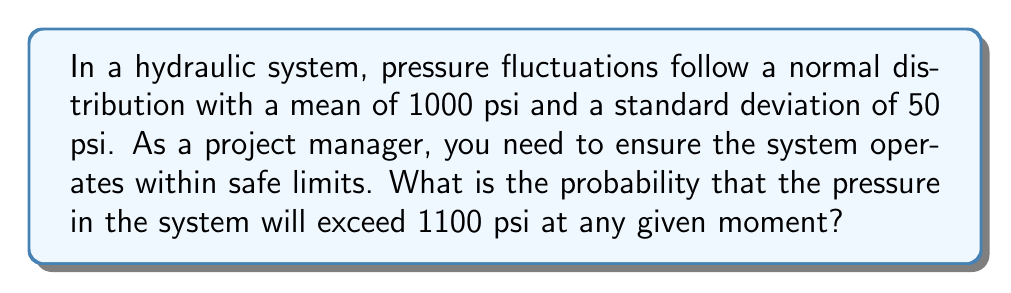Give your solution to this math problem. To solve this problem, we'll follow these steps:

1) We're dealing with a normal distribution where:
   $\mu = 1000$ psi (mean)
   $\sigma = 50$ psi (standard deviation)

2) We want to find $P(X > 1100)$, where $X$ is the pressure.

3) First, we need to standardize the value 1100 to a z-score:

   $$z = \frac{x - \mu}{\sigma} = \frac{1100 - 1000}{50} = 2$$

4) Now, we need to find $P(Z > 2)$, where $Z$ is the standard normal variable.

5) Using a standard normal table or calculator, we can find that:
   $P(Z < 2) = 0.9772$

6) Since we want $P(Z > 2)$, and the total probability is 1, we calculate:
   $P(Z > 2) = 1 - P(Z < 2) = 1 - 0.9772 = 0.0228$

7) Therefore, the probability of the pressure exceeding 1100 psi is 0.0228 or 2.28%.
Answer: 0.0228 